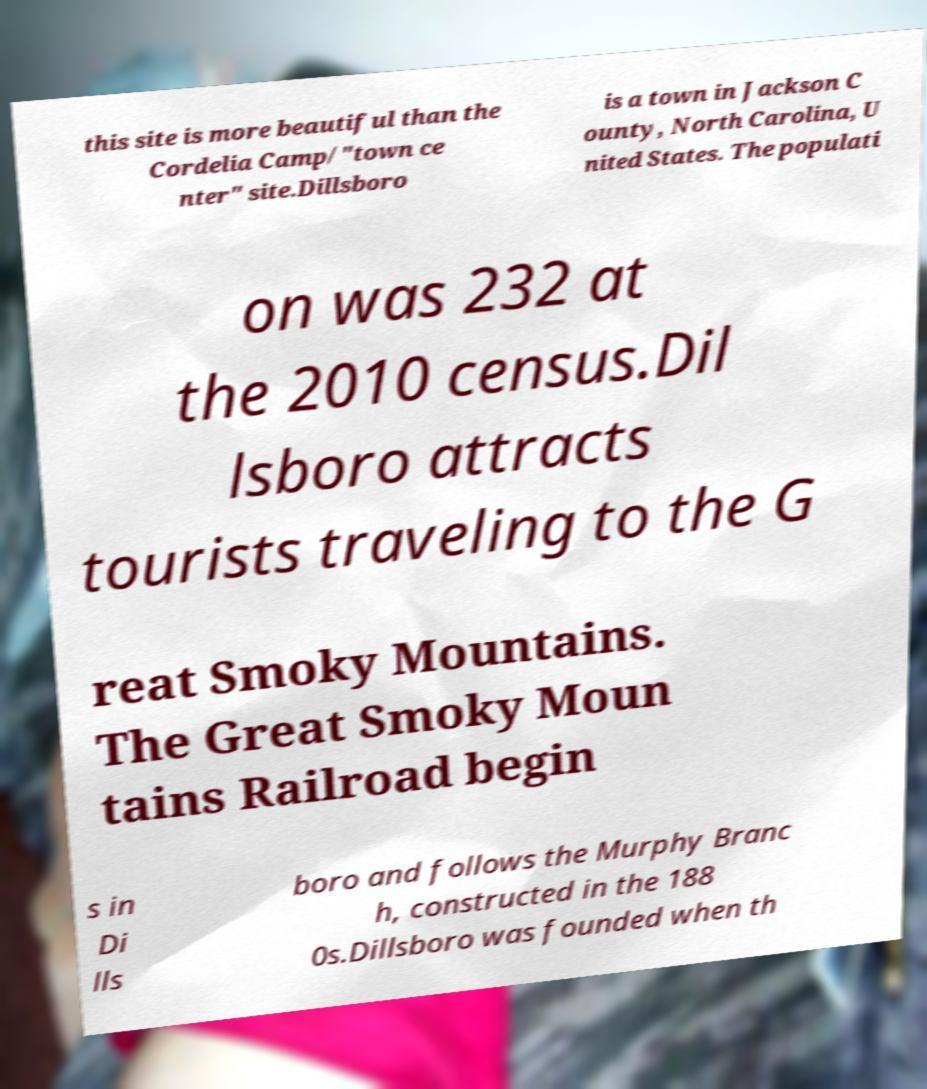Could you extract and type out the text from this image? this site is more beautiful than the Cordelia Camp/"town ce nter" site.Dillsboro is a town in Jackson C ounty, North Carolina, U nited States. The populati on was 232 at the 2010 census.Dil lsboro attracts tourists traveling to the G reat Smoky Mountains. The Great Smoky Moun tains Railroad begin s in Di lls boro and follows the Murphy Branc h, constructed in the 188 0s.Dillsboro was founded when th 